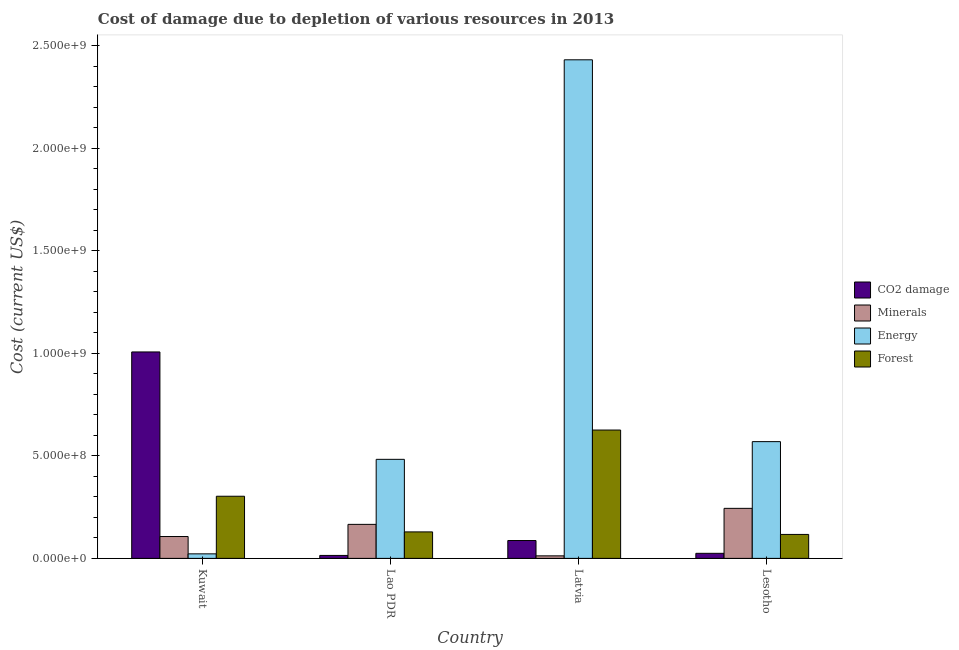Are the number of bars per tick equal to the number of legend labels?
Your answer should be very brief. Yes. How many bars are there on the 3rd tick from the left?
Ensure brevity in your answer.  4. What is the label of the 1st group of bars from the left?
Keep it short and to the point. Kuwait. What is the cost of damage due to depletion of minerals in Kuwait?
Offer a terse response. 1.07e+08. Across all countries, what is the maximum cost of damage due to depletion of forests?
Your answer should be very brief. 6.26e+08. Across all countries, what is the minimum cost of damage due to depletion of minerals?
Offer a very short reply. 1.24e+07. In which country was the cost of damage due to depletion of coal maximum?
Your answer should be compact. Kuwait. In which country was the cost of damage due to depletion of coal minimum?
Give a very brief answer. Lao PDR. What is the total cost of damage due to depletion of forests in the graph?
Ensure brevity in your answer.  1.18e+09. What is the difference between the cost of damage due to depletion of energy in Kuwait and that in Latvia?
Give a very brief answer. -2.41e+09. What is the difference between the cost of damage due to depletion of coal in Kuwait and the cost of damage due to depletion of forests in Latvia?
Your answer should be compact. 3.81e+08. What is the average cost of damage due to depletion of minerals per country?
Make the answer very short. 1.32e+08. What is the difference between the cost of damage due to depletion of coal and cost of damage due to depletion of energy in Lesotho?
Give a very brief answer. -5.45e+08. What is the ratio of the cost of damage due to depletion of energy in Kuwait to that in Lao PDR?
Your answer should be compact. 0.05. Is the cost of damage due to depletion of coal in Kuwait less than that in Lao PDR?
Your answer should be compact. No. What is the difference between the highest and the second highest cost of damage due to depletion of forests?
Your response must be concise. 3.23e+08. What is the difference between the highest and the lowest cost of damage due to depletion of energy?
Provide a succinct answer. 2.41e+09. Is the sum of the cost of damage due to depletion of energy in Kuwait and Lesotho greater than the maximum cost of damage due to depletion of minerals across all countries?
Your answer should be very brief. Yes. What does the 3rd bar from the left in Latvia represents?
Your response must be concise. Energy. What does the 2nd bar from the right in Lesotho represents?
Make the answer very short. Energy. Is it the case that in every country, the sum of the cost of damage due to depletion of coal and cost of damage due to depletion of minerals is greater than the cost of damage due to depletion of energy?
Provide a short and direct response. No. Are all the bars in the graph horizontal?
Offer a terse response. No. How many countries are there in the graph?
Make the answer very short. 4. Are the values on the major ticks of Y-axis written in scientific E-notation?
Give a very brief answer. Yes. Does the graph contain any zero values?
Offer a terse response. No. Where does the legend appear in the graph?
Ensure brevity in your answer.  Center right. How many legend labels are there?
Provide a succinct answer. 4. How are the legend labels stacked?
Give a very brief answer. Vertical. What is the title of the graph?
Your answer should be compact. Cost of damage due to depletion of various resources in 2013 . What is the label or title of the Y-axis?
Offer a terse response. Cost (current US$). What is the Cost (current US$) of CO2 damage in Kuwait?
Offer a terse response. 1.01e+09. What is the Cost (current US$) in Minerals in Kuwait?
Your response must be concise. 1.07e+08. What is the Cost (current US$) in Energy in Kuwait?
Offer a very short reply. 2.21e+07. What is the Cost (current US$) in Forest in Kuwait?
Your answer should be compact. 3.03e+08. What is the Cost (current US$) of CO2 damage in Lao PDR?
Give a very brief answer. 1.44e+07. What is the Cost (current US$) in Minerals in Lao PDR?
Give a very brief answer. 1.66e+08. What is the Cost (current US$) in Energy in Lao PDR?
Offer a terse response. 4.83e+08. What is the Cost (current US$) in Forest in Lao PDR?
Make the answer very short. 1.29e+08. What is the Cost (current US$) in CO2 damage in Latvia?
Provide a short and direct response. 8.71e+07. What is the Cost (current US$) of Minerals in Latvia?
Keep it short and to the point. 1.24e+07. What is the Cost (current US$) in Energy in Latvia?
Provide a succinct answer. 2.43e+09. What is the Cost (current US$) in Forest in Latvia?
Offer a terse response. 6.26e+08. What is the Cost (current US$) of CO2 damage in Lesotho?
Your response must be concise. 2.47e+07. What is the Cost (current US$) of Minerals in Lesotho?
Offer a terse response. 2.44e+08. What is the Cost (current US$) in Energy in Lesotho?
Provide a succinct answer. 5.70e+08. What is the Cost (current US$) in Forest in Lesotho?
Give a very brief answer. 1.17e+08. Across all countries, what is the maximum Cost (current US$) of CO2 damage?
Provide a short and direct response. 1.01e+09. Across all countries, what is the maximum Cost (current US$) in Minerals?
Your answer should be compact. 2.44e+08. Across all countries, what is the maximum Cost (current US$) in Energy?
Your answer should be very brief. 2.43e+09. Across all countries, what is the maximum Cost (current US$) of Forest?
Provide a succinct answer. 6.26e+08. Across all countries, what is the minimum Cost (current US$) of CO2 damage?
Provide a succinct answer. 1.44e+07. Across all countries, what is the minimum Cost (current US$) of Minerals?
Keep it short and to the point. 1.24e+07. Across all countries, what is the minimum Cost (current US$) in Energy?
Offer a terse response. 2.21e+07. Across all countries, what is the minimum Cost (current US$) in Forest?
Provide a succinct answer. 1.17e+08. What is the total Cost (current US$) of CO2 damage in the graph?
Offer a terse response. 1.13e+09. What is the total Cost (current US$) of Minerals in the graph?
Your answer should be very brief. 5.29e+08. What is the total Cost (current US$) of Energy in the graph?
Keep it short and to the point. 3.51e+09. What is the total Cost (current US$) of Forest in the graph?
Provide a short and direct response. 1.18e+09. What is the difference between the Cost (current US$) of CO2 damage in Kuwait and that in Lao PDR?
Provide a short and direct response. 9.93e+08. What is the difference between the Cost (current US$) in Minerals in Kuwait and that in Lao PDR?
Make the answer very short. -5.94e+07. What is the difference between the Cost (current US$) of Energy in Kuwait and that in Lao PDR?
Offer a very short reply. -4.61e+08. What is the difference between the Cost (current US$) of Forest in Kuwait and that in Lao PDR?
Your answer should be very brief. 1.74e+08. What is the difference between the Cost (current US$) of CO2 damage in Kuwait and that in Latvia?
Offer a very short reply. 9.20e+08. What is the difference between the Cost (current US$) in Minerals in Kuwait and that in Latvia?
Ensure brevity in your answer.  9.43e+07. What is the difference between the Cost (current US$) of Energy in Kuwait and that in Latvia?
Offer a very short reply. -2.41e+09. What is the difference between the Cost (current US$) of Forest in Kuwait and that in Latvia?
Ensure brevity in your answer.  -3.23e+08. What is the difference between the Cost (current US$) of CO2 damage in Kuwait and that in Lesotho?
Your response must be concise. 9.82e+08. What is the difference between the Cost (current US$) in Minerals in Kuwait and that in Lesotho?
Offer a terse response. -1.38e+08. What is the difference between the Cost (current US$) in Energy in Kuwait and that in Lesotho?
Your answer should be compact. -5.47e+08. What is the difference between the Cost (current US$) of Forest in Kuwait and that in Lesotho?
Give a very brief answer. 1.86e+08. What is the difference between the Cost (current US$) in CO2 damage in Lao PDR and that in Latvia?
Make the answer very short. -7.27e+07. What is the difference between the Cost (current US$) of Minerals in Lao PDR and that in Latvia?
Give a very brief answer. 1.54e+08. What is the difference between the Cost (current US$) of Energy in Lao PDR and that in Latvia?
Give a very brief answer. -1.95e+09. What is the difference between the Cost (current US$) in Forest in Lao PDR and that in Latvia?
Offer a terse response. -4.97e+08. What is the difference between the Cost (current US$) of CO2 damage in Lao PDR and that in Lesotho?
Offer a terse response. -1.03e+07. What is the difference between the Cost (current US$) of Minerals in Lao PDR and that in Lesotho?
Provide a succinct answer. -7.81e+07. What is the difference between the Cost (current US$) of Energy in Lao PDR and that in Lesotho?
Give a very brief answer. -8.63e+07. What is the difference between the Cost (current US$) in Forest in Lao PDR and that in Lesotho?
Your answer should be very brief. 1.24e+07. What is the difference between the Cost (current US$) in CO2 damage in Latvia and that in Lesotho?
Give a very brief answer. 6.24e+07. What is the difference between the Cost (current US$) in Minerals in Latvia and that in Lesotho?
Provide a succinct answer. -2.32e+08. What is the difference between the Cost (current US$) of Energy in Latvia and that in Lesotho?
Offer a terse response. 1.86e+09. What is the difference between the Cost (current US$) in Forest in Latvia and that in Lesotho?
Offer a terse response. 5.09e+08. What is the difference between the Cost (current US$) in CO2 damage in Kuwait and the Cost (current US$) in Minerals in Lao PDR?
Ensure brevity in your answer.  8.41e+08. What is the difference between the Cost (current US$) in CO2 damage in Kuwait and the Cost (current US$) in Energy in Lao PDR?
Your answer should be very brief. 5.24e+08. What is the difference between the Cost (current US$) of CO2 damage in Kuwait and the Cost (current US$) of Forest in Lao PDR?
Provide a short and direct response. 8.78e+08. What is the difference between the Cost (current US$) of Minerals in Kuwait and the Cost (current US$) of Energy in Lao PDR?
Provide a short and direct response. -3.77e+08. What is the difference between the Cost (current US$) of Minerals in Kuwait and the Cost (current US$) of Forest in Lao PDR?
Offer a terse response. -2.26e+07. What is the difference between the Cost (current US$) in Energy in Kuwait and the Cost (current US$) in Forest in Lao PDR?
Your answer should be very brief. -1.07e+08. What is the difference between the Cost (current US$) in CO2 damage in Kuwait and the Cost (current US$) in Minerals in Latvia?
Offer a terse response. 9.95e+08. What is the difference between the Cost (current US$) in CO2 damage in Kuwait and the Cost (current US$) in Energy in Latvia?
Offer a very short reply. -1.43e+09. What is the difference between the Cost (current US$) of CO2 damage in Kuwait and the Cost (current US$) of Forest in Latvia?
Provide a short and direct response. 3.81e+08. What is the difference between the Cost (current US$) of Minerals in Kuwait and the Cost (current US$) of Energy in Latvia?
Provide a short and direct response. -2.33e+09. What is the difference between the Cost (current US$) of Minerals in Kuwait and the Cost (current US$) of Forest in Latvia?
Offer a terse response. -5.20e+08. What is the difference between the Cost (current US$) of Energy in Kuwait and the Cost (current US$) of Forest in Latvia?
Keep it short and to the point. -6.04e+08. What is the difference between the Cost (current US$) in CO2 damage in Kuwait and the Cost (current US$) in Minerals in Lesotho?
Keep it short and to the point. 7.63e+08. What is the difference between the Cost (current US$) of CO2 damage in Kuwait and the Cost (current US$) of Energy in Lesotho?
Provide a short and direct response. 4.38e+08. What is the difference between the Cost (current US$) in CO2 damage in Kuwait and the Cost (current US$) in Forest in Lesotho?
Provide a succinct answer. 8.90e+08. What is the difference between the Cost (current US$) of Minerals in Kuwait and the Cost (current US$) of Energy in Lesotho?
Give a very brief answer. -4.63e+08. What is the difference between the Cost (current US$) of Minerals in Kuwait and the Cost (current US$) of Forest in Lesotho?
Offer a very short reply. -1.03e+07. What is the difference between the Cost (current US$) in Energy in Kuwait and the Cost (current US$) in Forest in Lesotho?
Provide a short and direct response. -9.48e+07. What is the difference between the Cost (current US$) in CO2 damage in Lao PDR and the Cost (current US$) in Minerals in Latvia?
Your response must be concise. 2.04e+06. What is the difference between the Cost (current US$) in CO2 damage in Lao PDR and the Cost (current US$) in Energy in Latvia?
Your response must be concise. -2.42e+09. What is the difference between the Cost (current US$) of CO2 damage in Lao PDR and the Cost (current US$) of Forest in Latvia?
Give a very brief answer. -6.12e+08. What is the difference between the Cost (current US$) of Minerals in Lao PDR and the Cost (current US$) of Energy in Latvia?
Offer a very short reply. -2.27e+09. What is the difference between the Cost (current US$) of Minerals in Lao PDR and the Cost (current US$) of Forest in Latvia?
Offer a terse response. -4.60e+08. What is the difference between the Cost (current US$) in Energy in Lao PDR and the Cost (current US$) in Forest in Latvia?
Your answer should be compact. -1.43e+08. What is the difference between the Cost (current US$) of CO2 damage in Lao PDR and the Cost (current US$) of Minerals in Lesotho?
Give a very brief answer. -2.30e+08. What is the difference between the Cost (current US$) in CO2 damage in Lao PDR and the Cost (current US$) in Energy in Lesotho?
Ensure brevity in your answer.  -5.55e+08. What is the difference between the Cost (current US$) of CO2 damage in Lao PDR and the Cost (current US$) of Forest in Lesotho?
Your answer should be very brief. -1.02e+08. What is the difference between the Cost (current US$) in Minerals in Lao PDR and the Cost (current US$) in Energy in Lesotho?
Make the answer very short. -4.04e+08. What is the difference between the Cost (current US$) in Minerals in Lao PDR and the Cost (current US$) in Forest in Lesotho?
Ensure brevity in your answer.  4.91e+07. What is the difference between the Cost (current US$) of Energy in Lao PDR and the Cost (current US$) of Forest in Lesotho?
Provide a succinct answer. 3.66e+08. What is the difference between the Cost (current US$) of CO2 damage in Latvia and the Cost (current US$) of Minerals in Lesotho?
Your response must be concise. -1.57e+08. What is the difference between the Cost (current US$) of CO2 damage in Latvia and the Cost (current US$) of Energy in Lesotho?
Offer a terse response. -4.82e+08. What is the difference between the Cost (current US$) in CO2 damage in Latvia and the Cost (current US$) in Forest in Lesotho?
Your answer should be compact. -2.97e+07. What is the difference between the Cost (current US$) of Minerals in Latvia and the Cost (current US$) of Energy in Lesotho?
Provide a short and direct response. -5.57e+08. What is the difference between the Cost (current US$) in Minerals in Latvia and the Cost (current US$) in Forest in Lesotho?
Give a very brief answer. -1.05e+08. What is the difference between the Cost (current US$) of Energy in Latvia and the Cost (current US$) of Forest in Lesotho?
Give a very brief answer. 2.32e+09. What is the average Cost (current US$) in CO2 damage per country?
Your answer should be compact. 2.83e+08. What is the average Cost (current US$) of Minerals per country?
Give a very brief answer. 1.32e+08. What is the average Cost (current US$) in Energy per country?
Ensure brevity in your answer.  8.77e+08. What is the average Cost (current US$) of Forest per country?
Provide a short and direct response. 2.94e+08. What is the difference between the Cost (current US$) in CO2 damage and Cost (current US$) in Minerals in Kuwait?
Offer a very short reply. 9.01e+08. What is the difference between the Cost (current US$) in CO2 damage and Cost (current US$) in Energy in Kuwait?
Provide a succinct answer. 9.85e+08. What is the difference between the Cost (current US$) in CO2 damage and Cost (current US$) in Forest in Kuwait?
Your response must be concise. 7.04e+08. What is the difference between the Cost (current US$) of Minerals and Cost (current US$) of Energy in Kuwait?
Your answer should be compact. 8.45e+07. What is the difference between the Cost (current US$) in Minerals and Cost (current US$) in Forest in Kuwait?
Ensure brevity in your answer.  -1.97e+08. What is the difference between the Cost (current US$) of Energy and Cost (current US$) of Forest in Kuwait?
Your answer should be very brief. -2.81e+08. What is the difference between the Cost (current US$) in CO2 damage and Cost (current US$) in Minerals in Lao PDR?
Offer a terse response. -1.52e+08. What is the difference between the Cost (current US$) in CO2 damage and Cost (current US$) in Energy in Lao PDR?
Your answer should be very brief. -4.69e+08. What is the difference between the Cost (current US$) of CO2 damage and Cost (current US$) of Forest in Lao PDR?
Your response must be concise. -1.15e+08. What is the difference between the Cost (current US$) in Minerals and Cost (current US$) in Energy in Lao PDR?
Keep it short and to the point. -3.17e+08. What is the difference between the Cost (current US$) of Minerals and Cost (current US$) of Forest in Lao PDR?
Keep it short and to the point. 3.67e+07. What is the difference between the Cost (current US$) of Energy and Cost (current US$) of Forest in Lao PDR?
Make the answer very short. 3.54e+08. What is the difference between the Cost (current US$) of CO2 damage and Cost (current US$) of Minerals in Latvia?
Your answer should be very brief. 7.48e+07. What is the difference between the Cost (current US$) in CO2 damage and Cost (current US$) in Energy in Latvia?
Give a very brief answer. -2.35e+09. What is the difference between the Cost (current US$) in CO2 damage and Cost (current US$) in Forest in Latvia?
Provide a short and direct response. -5.39e+08. What is the difference between the Cost (current US$) in Minerals and Cost (current US$) in Energy in Latvia?
Your answer should be compact. -2.42e+09. What is the difference between the Cost (current US$) in Minerals and Cost (current US$) in Forest in Latvia?
Your answer should be very brief. -6.14e+08. What is the difference between the Cost (current US$) of Energy and Cost (current US$) of Forest in Latvia?
Your answer should be compact. 1.81e+09. What is the difference between the Cost (current US$) of CO2 damage and Cost (current US$) of Minerals in Lesotho?
Offer a very short reply. -2.19e+08. What is the difference between the Cost (current US$) in CO2 damage and Cost (current US$) in Energy in Lesotho?
Provide a succinct answer. -5.45e+08. What is the difference between the Cost (current US$) of CO2 damage and Cost (current US$) of Forest in Lesotho?
Ensure brevity in your answer.  -9.22e+07. What is the difference between the Cost (current US$) in Minerals and Cost (current US$) in Energy in Lesotho?
Provide a short and direct response. -3.25e+08. What is the difference between the Cost (current US$) of Minerals and Cost (current US$) of Forest in Lesotho?
Offer a terse response. 1.27e+08. What is the difference between the Cost (current US$) of Energy and Cost (current US$) of Forest in Lesotho?
Your answer should be compact. 4.53e+08. What is the ratio of the Cost (current US$) of CO2 damage in Kuwait to that in Lao PDR?
Offer a very short reply. 69.86. What is the ratio of the Cost (current US$) in Minerals in Kuwait to that in Lao PDR?
Keep it short and to the point. 0.64. What is the ratio of the Cost (current US$) in Energy in Kuwait to that in Lao PDR?
Make the answer very short. 0.05. What is the ratio of the Cost (current US$) in Forest in Kuwait to that in Lao PDR?
Your response must be concise. 2.35. What is the ratio of the Cost (current US$) of CO2 damage in Kuwait to that in Latvia?
Your answer should be compact. 11.56. What is the ratio of the Cost (current US$) of Minerals in Kuwait to that in Latvia?
Your answer should be very brief. 8.62. What is the ratio of the Cost (current US$) of Energy in Kuwait to that in Latvia?
Your answer should be very brief. 0.01. What is the ratio of the Cost (current US$) in Forest in Kuwait to that in Latvia?
Your answer should be compact. 0.48. What is the ratio of the Cost (current US$) of CO2 damage in Kuwait to that in Lesotho?
Keep it short and to the point. 40.76. What is the ratio of the Cost (current US$) of Minerals in Kuwait to that in Lesotho?
Give a very brief answer. 0.44. What is the ratio of the Cost (current US$) in Energy in Kuwait to that in Lesotho?
Offer a very short reply. 0.04. What is the ratio of the Cost (current US$) in Forest in Kuwait to that in Lesotho?
Your answer should be compact. 2.59. What is the ratio of the Cost (current US$) in CO2 damage in Lao PDR to that in Latvia?
Make the answer very short. 0.17. What is the ratio of the Cost (current US$) of Minerals in Lao PDR to that in Latvia?
Make the answer very short. 13.41. What is the ratio of the Cost (current US$) in Energy in Lao PDR to that in Latvia?
Offer a terse response. 0.2. What is the ratio of the Cost (current US$) in Forest in Lao PDR to that in Latvia?
Your answer should be compact. 0.21. What is the ratio of the Cost (current US$) in CO2 damage in Lao PDR to that in Lesotho?
Your answer should be compact. 0.58. What is the ratio of the Cost (current US$) in Minerals in Lao PDR to that in Lesotho?
Give a very brief answer. 0.68. What is the ratio of the Cost (current US$) of Energy in Lao PDR to that in Lesotho?
Provide a short and direct response. 0.85. What is the ratio of the Cost (current US$) of Forest in Lao PDR to that in Lesotho?
Your answer should be compact. 1.11. What is the ratio of the Cost (current US$) of CO2 damage in Latvia to that in Lesotho?
Ensure brevity in your answer.  3.53. What is the ratio of the Cost (current US$) in Minerals in Latvia to that in Lesotho?
Provide a short and direct response. 0.05. What is the ratio of the Cost (current US$) in Energy in Latvia to that in Lesotho?
Provide a short and direct response. 4.27. What is the ratio of the Cost (current US$) of Forest in Latvia to that in Lesotho?
Provide a short and direct response. 5.36. What is the difference between the highest and the second highest Cost (current US$) of CO2 damage?
Give a very brief answer. 9.20e+08. What is the difference between the highest and the second highest Cost (current US$) of Minerals?
Offer a very short reply. 7.81e+07. What is the difference between the highest and the second highest Cost (current US$) of Energy?
Offer a terse response. 1.86e+09. What is the difference between the highest and the second highest Cost (current US$) of Forest?
Keep it short and to the point. 3.23e+08. What is the difference between the highest and the lowest Cost (current US$) in CO2 damage?
Provide a short and direct response. 9.93e+08. What is the difference between the highest and the lowest Cost (current US$) of Minerals?
Your response must be concise. 2.32e+08. What is the difference between the highest and the lowest Cost (current US$) in Energy?
Your response must be concise. 2.41e+09. What is the difference between the highest and the lowest Cost (current US$) in Forest?
Give a very brief answer. 5.09e+08. 